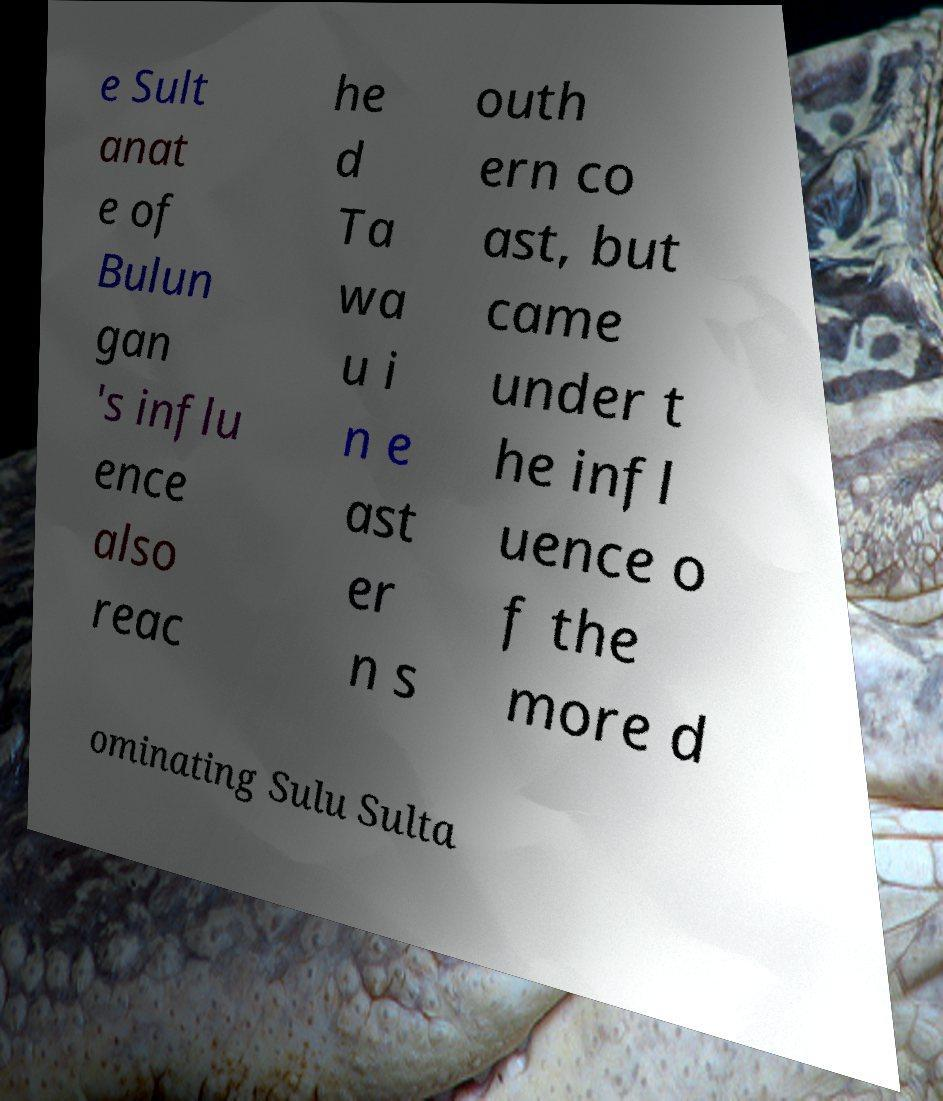There's text embedded in this image that I need extracted. Can you transcribe it verbatim? e Sult anat e of Bulun gan 's influ ence also reac he d Ta wa u i n e ast er n s outh ern co ast, but came under t he infl uence o f the more d ominating Sulu Sulta 